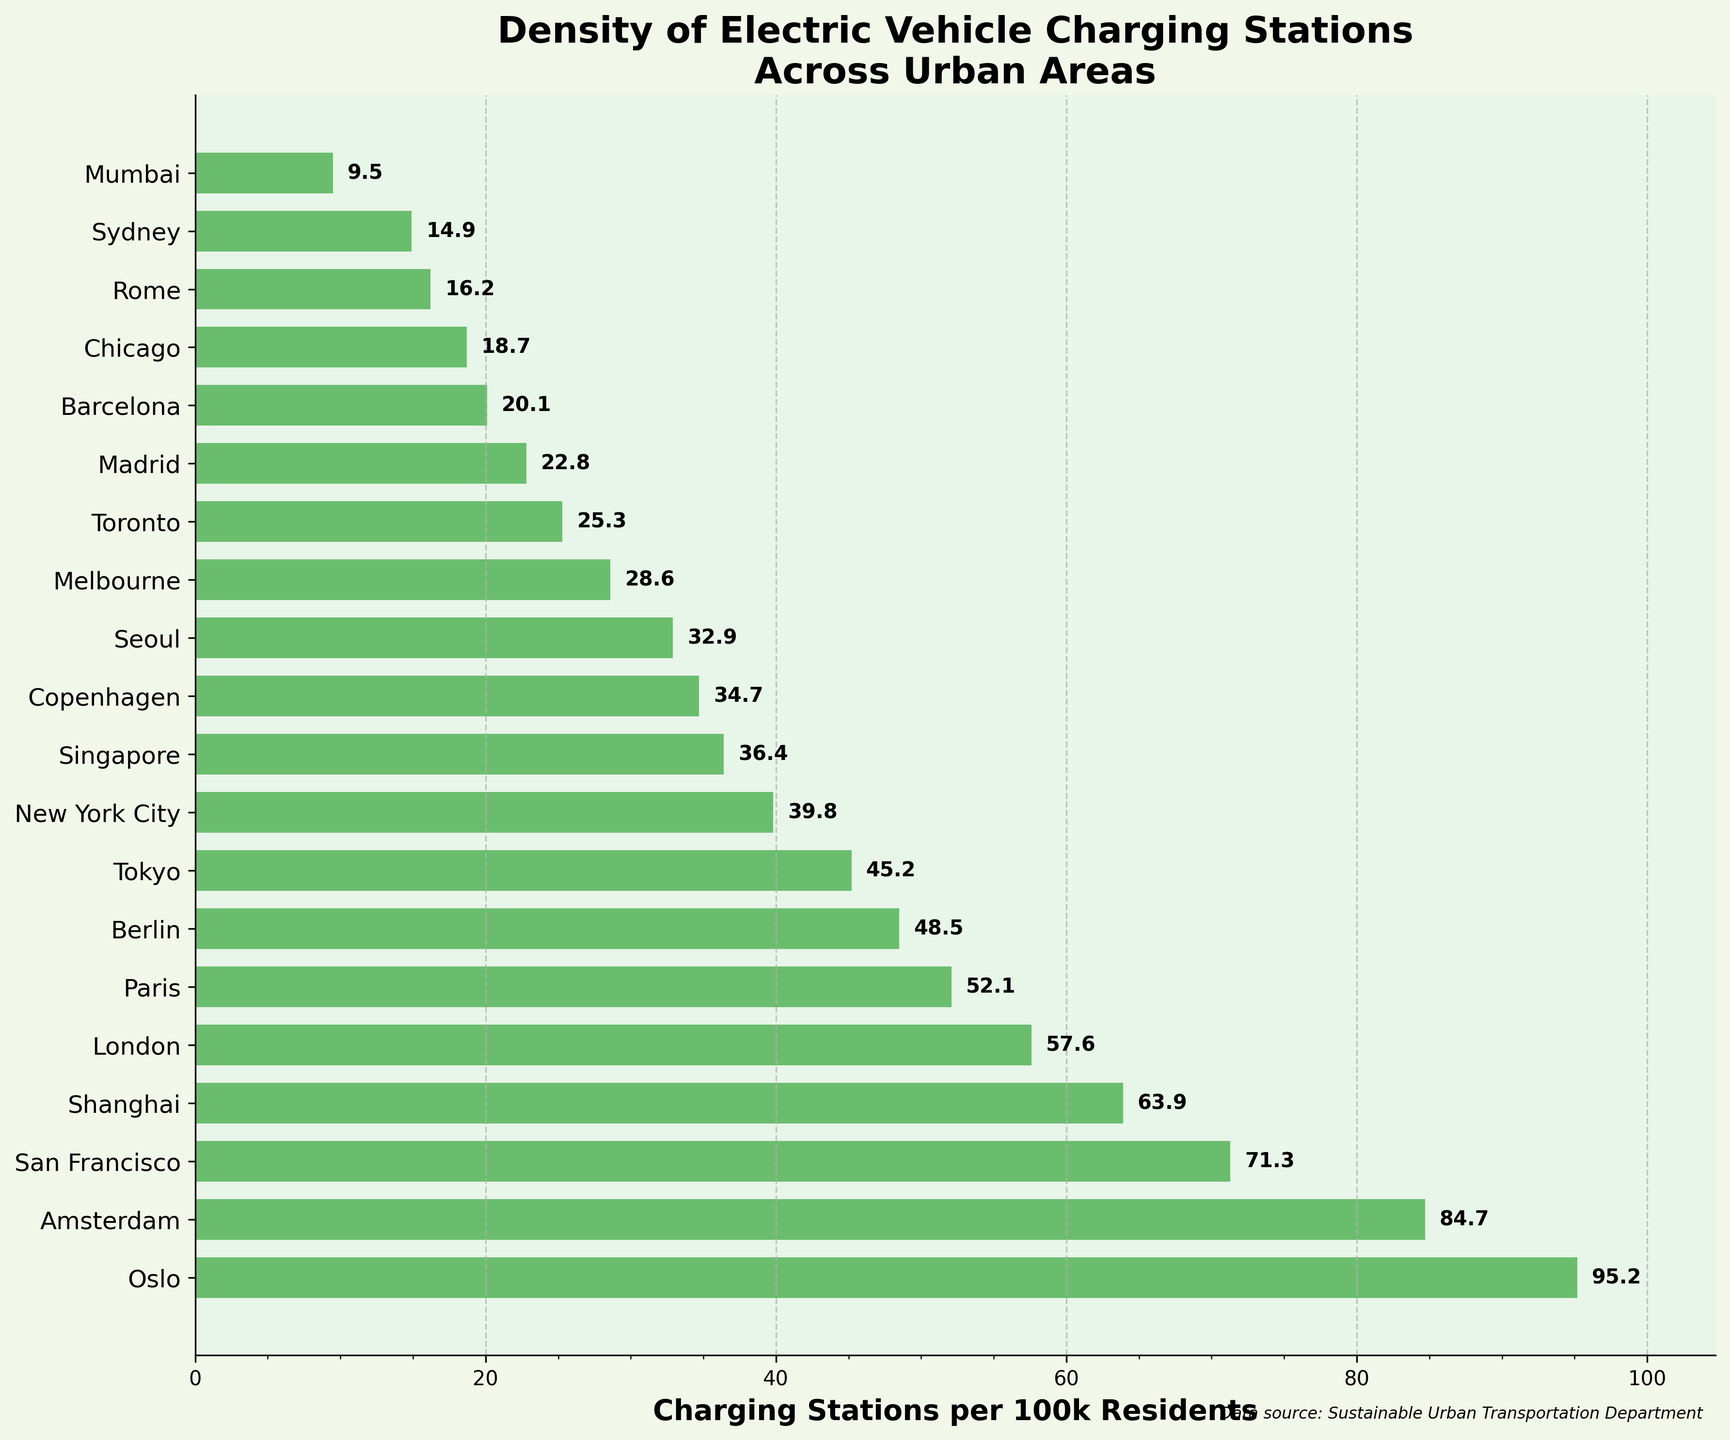What's the title of the figure? The title of a plot is usually found at the top. In this case, the title is "Density of Electric Vehicle Charging Stations Across Urban Areas."
Answer: Density of Electric Vehicle Charging Stations Across Urban Areas What is the unit of measurement on the x-axis? The unit of measurement on the x-axis is typically labeled next to the axis. Here, the x-axis is labeled as "Charging Stations per 100k Residents."
Answer: Charging Stations per 100k Residents Which city has the highest density of electric vehicle charging stations? To find this, locate the bar that extends the farthest to the right. The city corresponding to this bar is Oslo with a density of 95.2 charging stations per 100k residents.
Answer: Oslo How many cities have a density greater than 50 charging stations per 100k residents? Count all the bars that extend beyond the 50 mark on the x-axis. These cities are Oslo, Amsterdam, San Francisco, Shanghai, London, and Paris, totaling six cities.
Answer: 6 What is the difference in the density of charging stations between Tokyo and New York City? Check the length of bars for Tokyo and New York City. Tokyo has 45.2 and New York City has 39.8. Subtract the smaller number from the larger: 45.2 - 39.8 = 5.4.
Answer: 5.4 Which cities have a density less than 20 charging stations per 100k residents? Find the bars that do not extend beyond the 20 mark on the x-axis. These cities are Barcelona, Chicago, Rome, Sydney, and Mumbai.
Answer: Barcelona, Chicago, Rome, Sydney, and Mumbai What is the median density value across all the cities? List all densities in ascending order: 9.5, 14.9, 16.2, 18.7, 20.1, 22.8, 25.3, 28.6, 32.9, 34.7, 36.4, 39.8, 45.2, 48.5, 52.1, 57.6, 63.9, 71.3, 84.7, 95.2. With 20 values, the median will be the average of the 10th and 11th values: (34.7 + 36.4) / 2 = 35.55.
Answer: 35.55 Which cities have nearly the same density value? Look for bars that are nearly equal in length. Berlin (48.5) and Tokyo (45.2) have very close values.
Answer: Berlin and Tokyo What is the average density of charging stations for all cities? Sum up all the density values and divide by the number of cities. (95.2 + 84.7 + 71.3 + 63.9 + 57.6 + 52.1 + 48.5 + 45.2 + 39.8 + 36.4 + 34.7 + 32.9 + 28.6 + 25.3 + 22.8 + 20.1 + 18.7 + 16.2 + 14.9 + 9.5) / 20 = 42.84.
Answer: 42.84 Which city has the lowest density of electric vehicle charging stations? Identify the bar that extends the least to the right. The city corresponding to this bar is Mumbai with a density of 9.5 charging stations per 100k residents.
Answer: Mumbai 